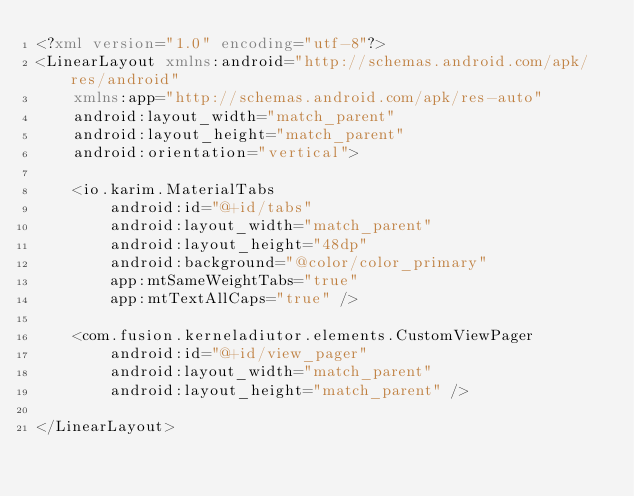<code> <loc_0><loc_0><loc_500><loc_500><_XML_><?xml version="1.0" encoding="utf-8"?>
<LinearLayout xmlns:android="http://schemas.android.com/apk/res/android"
    xmlns:app="http://schemas.android.com/apk/res-auto"
    android:layout_width="match_parent"
    android:layout_height="match_parent"
    android:orientation="vertical">

    <io.karim.MaterialTabs
        android:id="@+id/tabs"
        android:layout_width="match_parent"
        android:layout_height="48dp"
        android:background="@color/color_primary"
        app:mtSameWeightTabs="true"
        app:mtTextAllCaps="true" />

    <com.fusion.kerneladiutor.elements.CustomViewPager
        android:id="@+id/view_pager"
        android:layout_width="match_parent"
        android:layout_height="match_parent" />

</LinearLayout>
</code> 